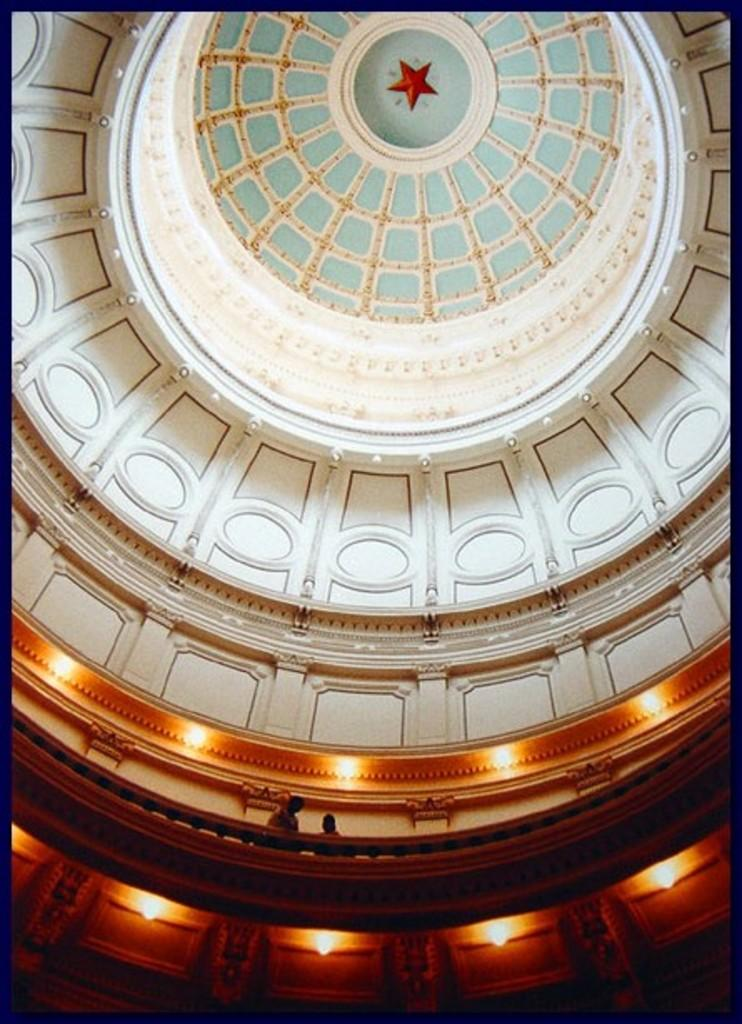What is the main subject of the image? The main subject of the image is a picture of a roof. Where was the picture taken from? The picture was taken from inside a palace. Can you describe the setting of the image? The image shows a palace interior with stairs and two people standing on the floor above the stairs. What type of fire can be seen burning in the image? There is no fire present in the image; it features a picture of a roof taken from inside a palace. What is the purpose of the sack in the image? There is no sack present in the image. 